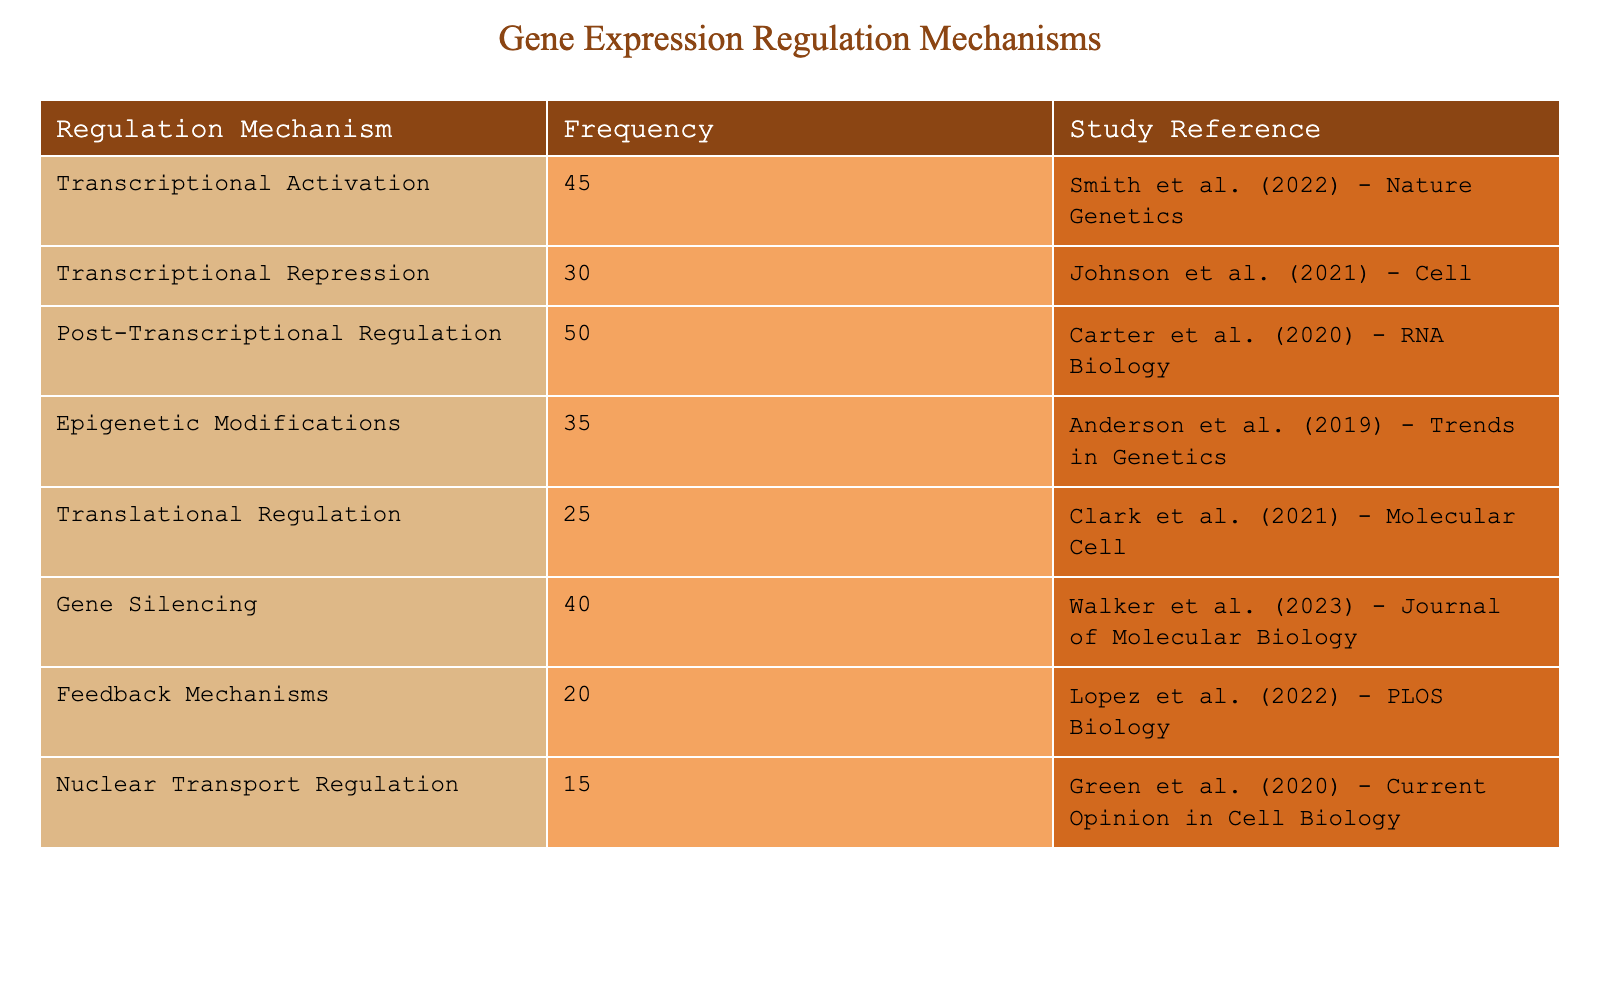What is the frequency of Post-Transcriptional Regulation? The table shows that the frequency of Post-Transcriptional Regulation is explicitly listed as 50.
Answer: 50 What are the study references for the two mechanisms with the highest frequencies? The table indicates that the mechanisms with the highest frequencies are Post-Transcriptional Regulation (50), and Transcriptional Activation (45). The respective study references are "Carter et al. (2020) - RNA Biology" and "Smith et al. (2022) - Nature Genetics."
Answer: Carter et al. (2020) - RNA Biology; Smith et al. (2022) - Nature Genetics Is the frequency of Nuclear Transport Regulation greater than that of Translational Regulation? According to the table, Nuclear Transport Regulation has a frequency of 15, while Translational Regulation has a frequency of 25. Therefore, the frequency of Nuclear Transport Regulation is not greater.
Answer: No What is the total frequency of all regulation mechanisms listed in the table? The frequencies are as follows: 45 + 30 + 50 + 35 + 25 + 40 + 20 + 15 = 315. Therefore, the total frequency is 315.
Answer: 315 What is the average frequency of the regulation mechanisms listed? To find the average, first sum the frequencies (315) and then divide by the number of mechanisms (8). Thus, the average is 315 / 8 = 39.375.
Answer: 39.375 Is there a regulation mechanism with a frequency of 25? The table shows that Translational Regulation has a frequency of 25, confirming that there is indeed a mechanism with this frequency.
Answer: Yes What is the difference in frequency between Gene Silencing and Transcriptional Repression? The frequency for Gene Silencing is 40 and for Transcriptional Repression it is 30. The difference is calculated as 40 - 30 = 10.
Answer: 10 Which regulation mechanism has the lowest frequency among those listed? Upon examining the table, Nuclear Transport Regulation has the lowest frequency of 15, making it the least frequent mechanism.
Answer: Nuclear Transport Regulation How many mechanisms have a frequency of 30 or higher? The mechanisms with frequencies of 30 or higher are: Transcriptional Activation (45), Post-Transcriptional Regulation (50), Epigenetic Modifications (35), Gene Silencing (40), and Translational Regulation (25). This totals to 5 mechanisms.
Answer: 5 What percentage of the total frequency is attributed to Feedback Mechanisms? Feedback Mechanisms has a frequency of 20. The total frequency is 315. To find the percentage, calculate (20 / 315) * 100 = 6.35%.
Answer: 6.35% 